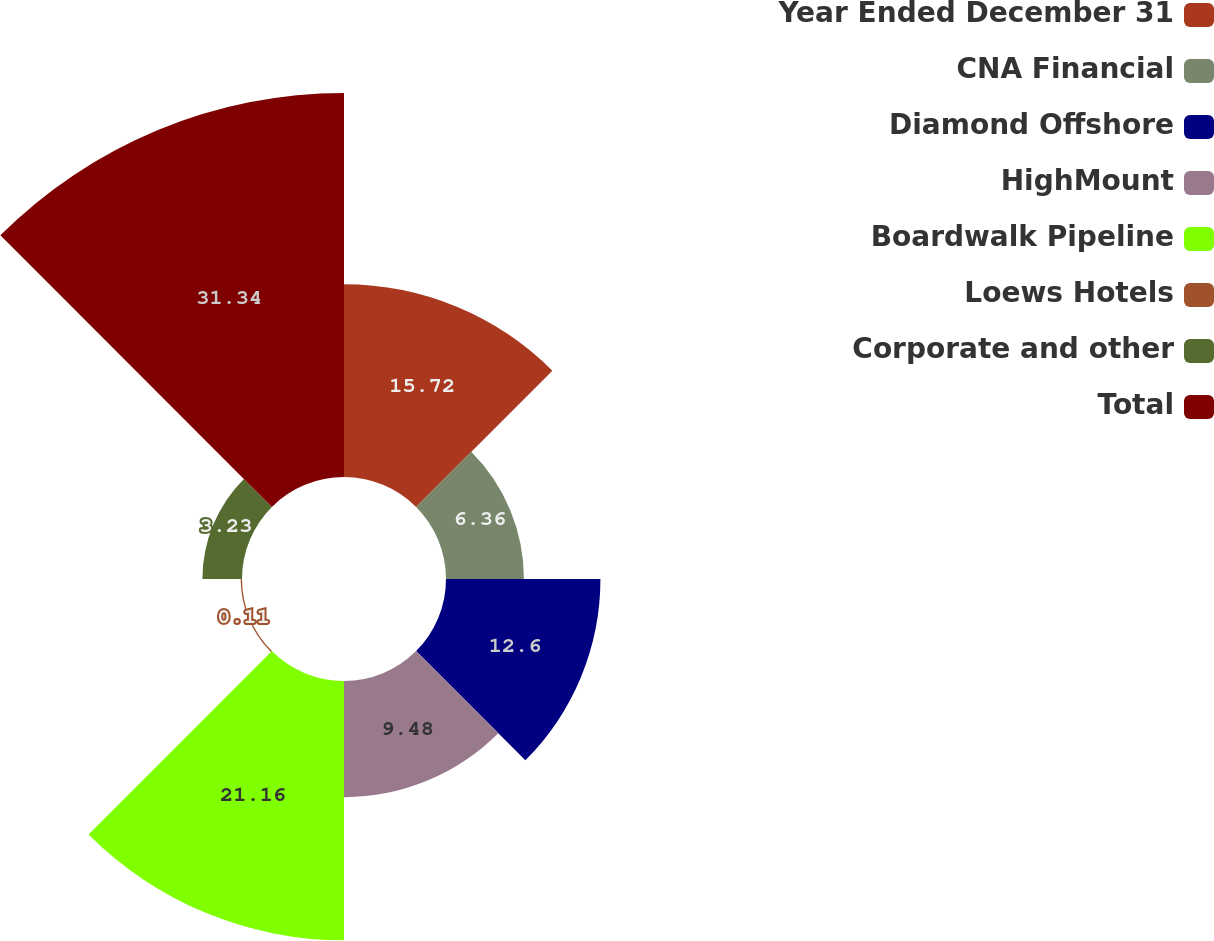Convert chart. <chart><loc_0><loc_0><loc_500><loc_500><pie_chart><fcel>Year Ended December 31<fcel>CNA Financial<fcel>Diamond Offshore<fcel>HighMount<fcel>Boardwalk Pipeline<fcel>Loews Hotels<fcel>Corporate and other<fcel>Total<nl><fcel>15.72%<fcel>6.36%<fcel>12.6%<fcel>9.48%<fcel>21.16%<fcel>0.11%<fcel>3.23%<fcel>31.33%<nl></chart> 